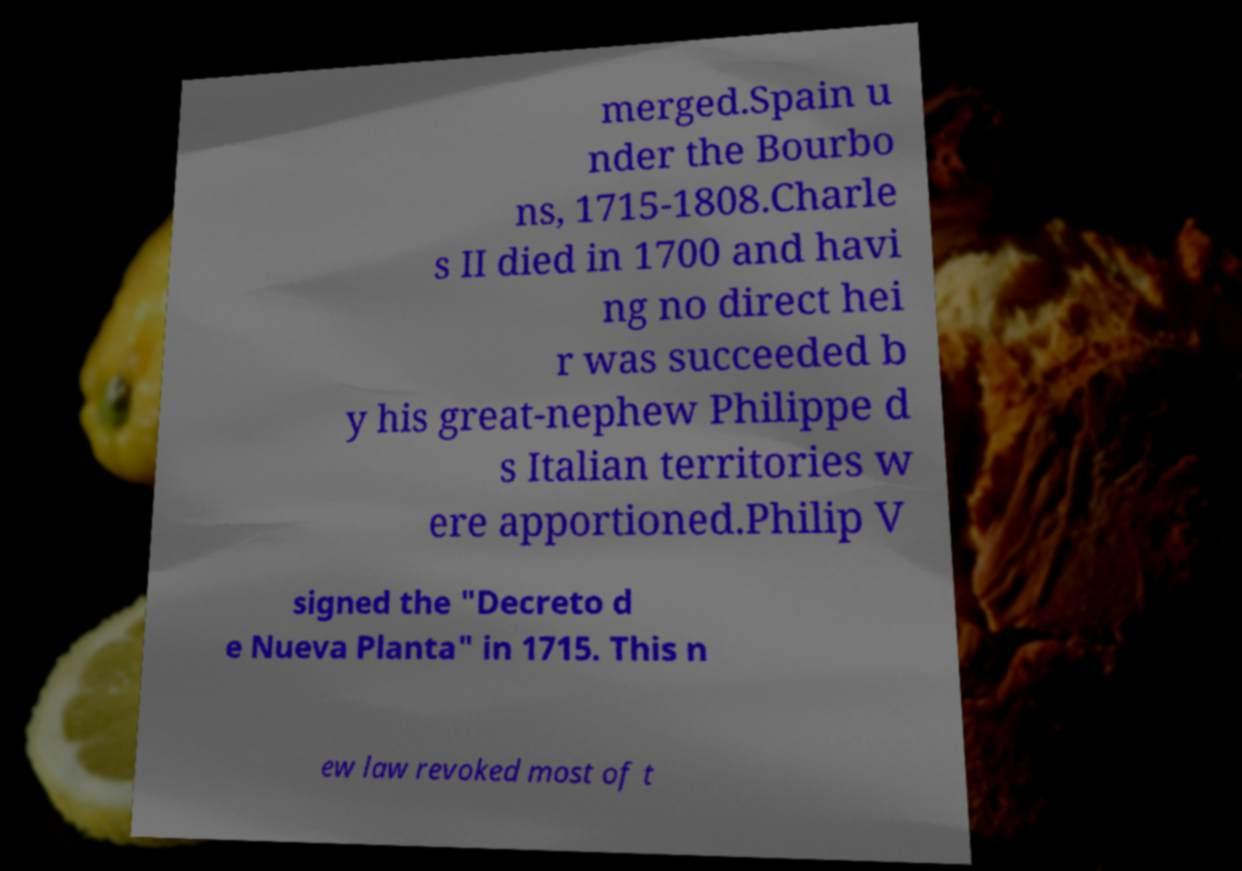Can you accurately transcribe the text from the provided image for me? merged.Spain u nder the Bourbo ns, 1715-1808.Charle s II died in 1700 and havi ng no direct hei r was succeeded b y his great-nephew Philippe d s Italian territories w ere apportioned.Philip V signed the "Decreto d e Nueva Planta" in 1715. This n ew law revoked most of t 